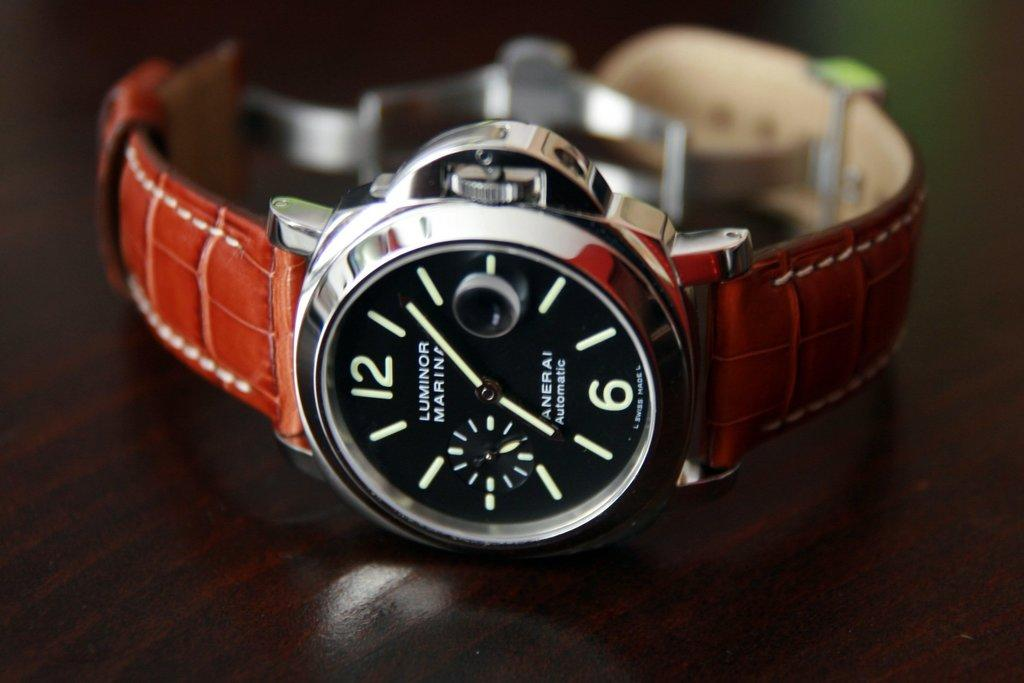<image>
Present a compact description of the photo's key features. A Luminor Marina watch has a brown leather band. 